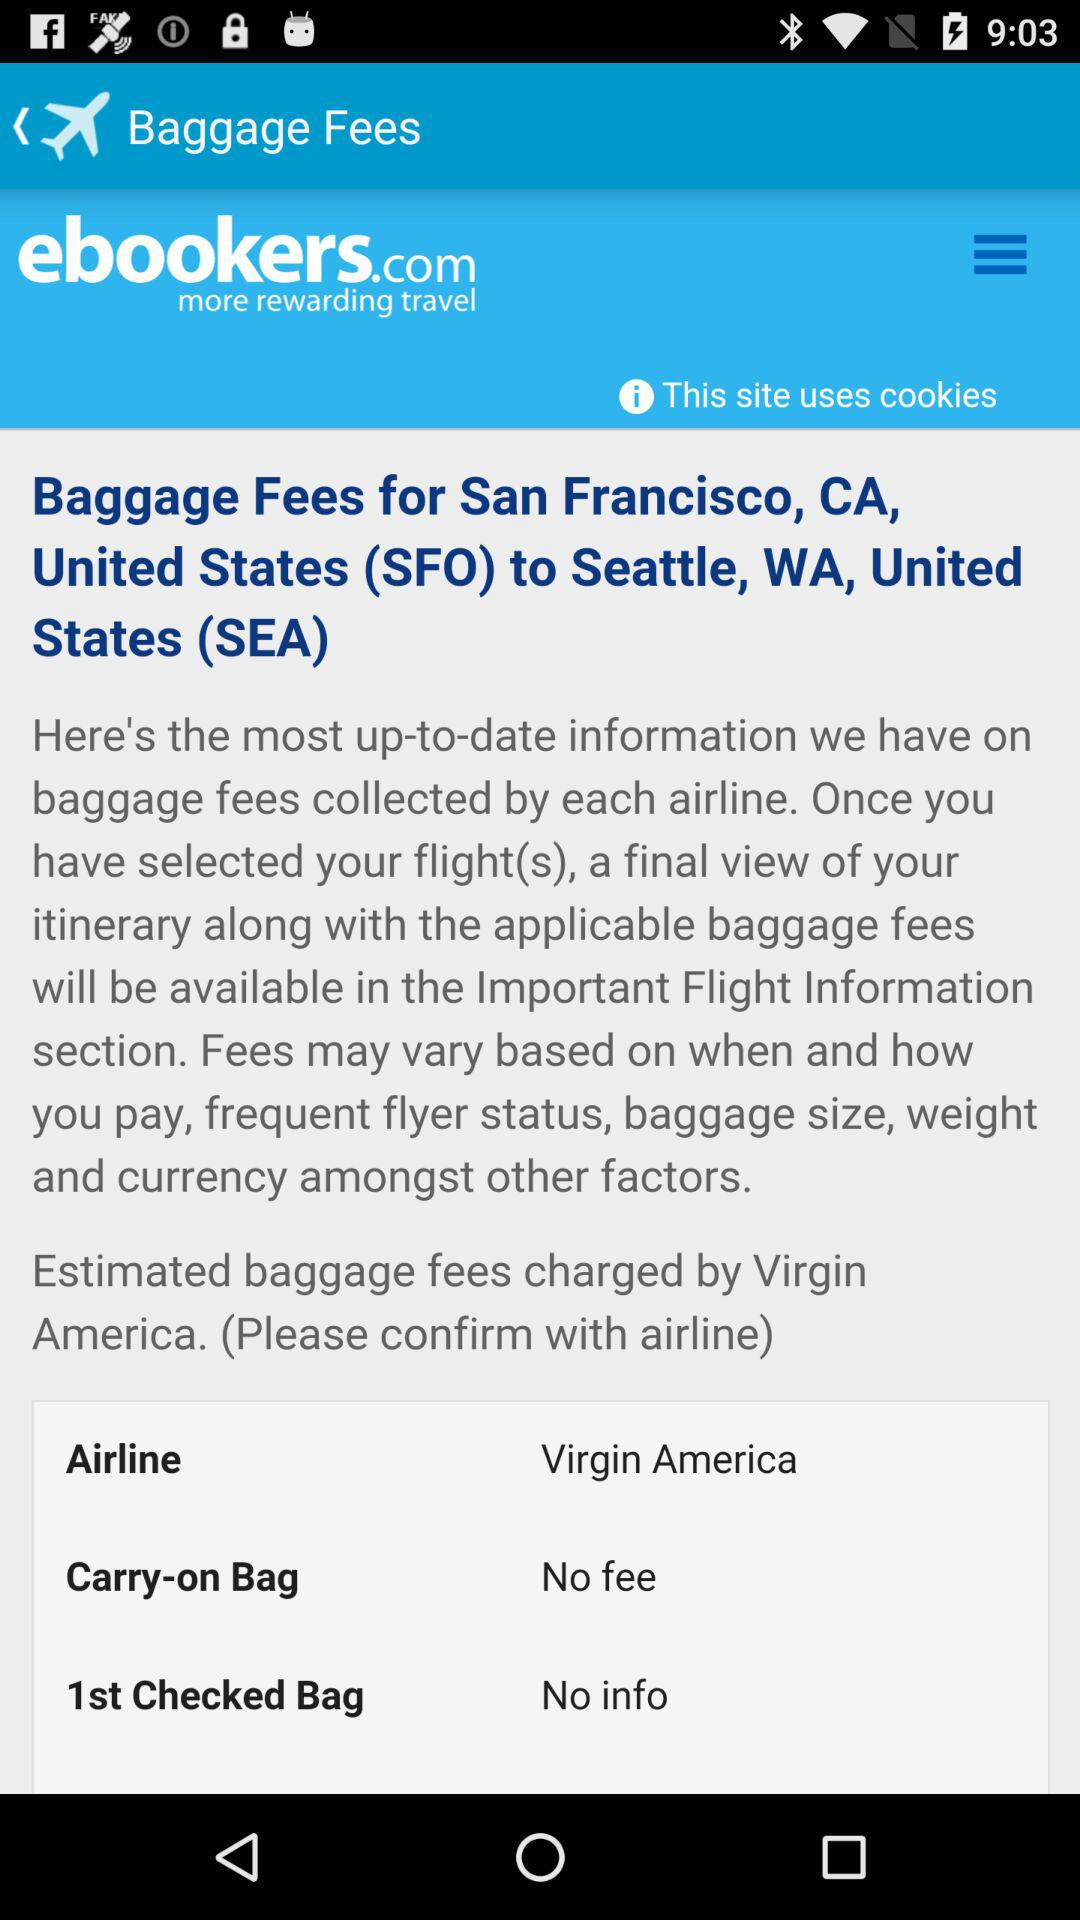What is the name of the booking website? The name of the booking website is ebookers.com. 